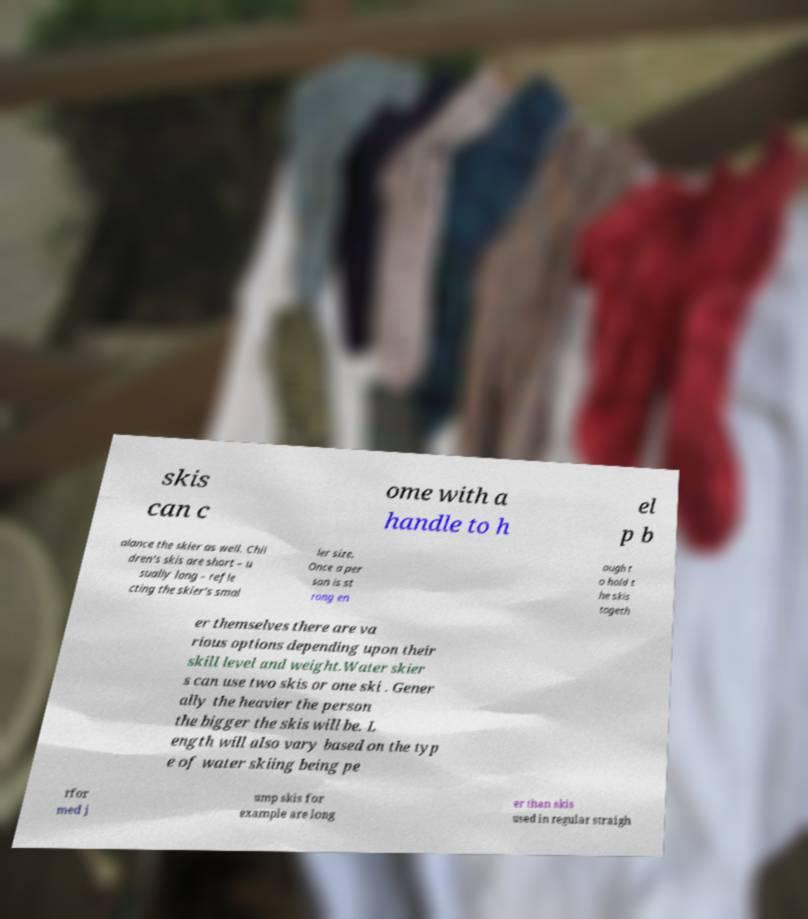There's text embedded in this image that I need extracted. Can you transcribe it verbatim? skis can c ome with a handle to h el p b alance the skier as well. Chil dren's skis are short – u sually long – refle cting the skier's smal ler size. Once a per son is st rong en ough t o hold t he skis togeth er themselves there are va rious options depending upon their skill level and weight.Water skier s can use two skis or one ski . Gener ally the heavier the person the bigger the skis will be. L ength will also vary based on the typ e of water skiing being pe rfor med j ump skis for example are long er than skis used in regular straigh 